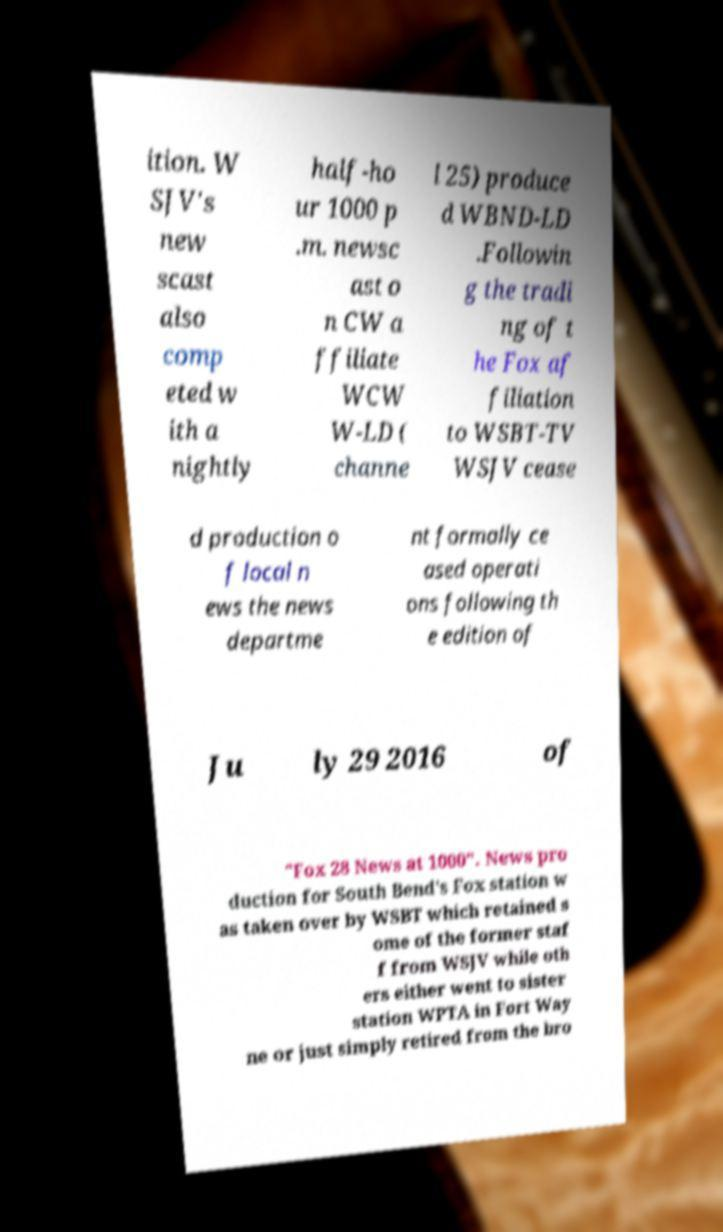Please read and relay the text visible in this image. What does it say? ition. W SJV's new scast also comp eted w ith a nightly half-ho ur 1000 p .m. newsc ast o n CW a ffiliate WCW W-LD ( channe l 25) produce d WBND-LD .Followin g the tradi ng of t he Fox af filiation to WSBT-TV WSJV cease d production o f local n ews the news departme nt formally ce ased operati ons following th e edition of Ju ly 29 2016 of "Fox 28 News at 1000". News pro duction for South Bend's Fox station w as taken over by WSBT which retained s ome of the former staf f from WSJV while oth ers either went to sister station WPTA in Fort Way ne or just simply retired from the bro 